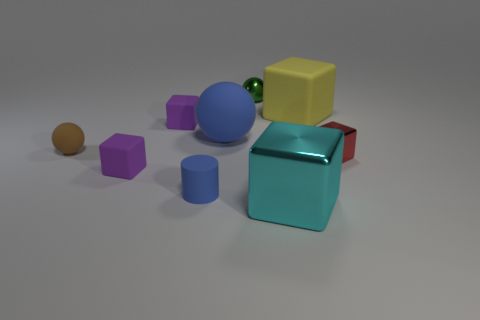Subtract all cyan cubes. How many cubes are left? 4 Subtract all red blocks. How many blocks are left? 4 Subtract all red blocks. Subtract all gray cylinders. How many blocks are left? 4 Add 1 cyan cubes. How many objects exist? 10 Subtract all cubes. How many objects are left? 4 Subtract all large brown rubber cylinders. Subtract all big yellow blocks. How many objects are left? 8 Add 3 red blocks. How many red blocks are left? 4 Add 3 tiny cylinders. How many tiny cylinders exist? 4 Subtract 0 purple cylinders. How many objects are left? 9 